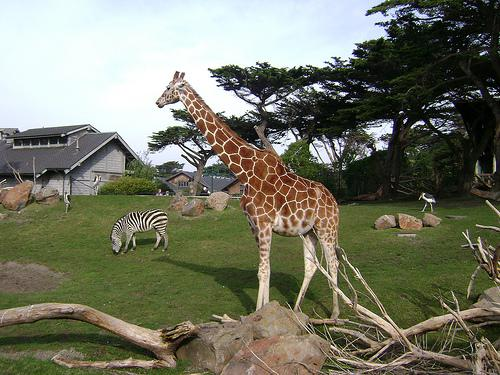Question: who has a long neck?
Choices:
A. Giraffe.
B. The man.
C. A zebra.
D. The lizard.
Answer with the letter. Answer: A Question: what is black and white?
Choices:
A. Zebra.
B. Horse.
C. Dog.
D. Cow.
Answer with the letter. Answer: A Question: what color is the giraffe?
Choices:
A. Brown and white.
B. Brown and tan.
C. Dark brown and light brown.
D. Tan.
Answer with the letter. Answer: A Question: why is there grass?
Choices:
A. To sit on.
B. It is growing.
C. Feed animals.
D. To decorate.
Answer with the letter. Answer: C 